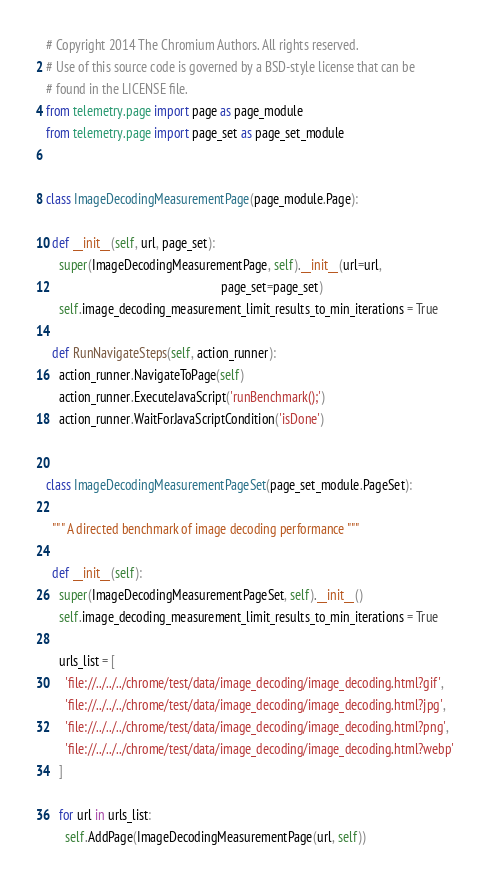<code> <loc_0><loc_0><loc_500><loc_500><_Python_># Copyright 2014 The Chromium Authors. All rights reserved.
# Use of this source code is governed by a BSD-style license that can be
# found in the LICENSE file.
from telemetry.page import page as page_module
from telemetry.page import page_set as page_set_module


class ImageDecodingMeasurementPage(page_module.Page):

  def __init__(self, url, page_set):
    super(ImageDecodingMeasurementPage, self).__init__(url=url,
                                                       page_set=page_set)
    self.image_decoding_measurement_limit_results_to_min_iterations = True

  def RunNavigateSteps(self, action_runner):
    action_runner.NavigateToPage(self)
    action_runner.ExecuteJavaScript('runBenchmark();')
    action_runner.WaitForJavaScriptCondition('isDone')


class ImageDecodingMeasurementPageSet(page_set_module.PageSet):

  """ A directed benchmark of image decoding performance """

  def __init__(self):
    super(ImageDecodingMeasurementPageSet, self).__init__()
    self.image_decoding_measurement_limit_results_to_min_iterations = True

    urls_list = [
      'file://../../../chrome/test/data/image_decoding/image_decoding.html?gif',
      'file://../../../chrome/test/data/image_decoding/image_decoding.html?jpg',
      'file://../../../chrome/test/data/image_decoding/image_decoding.html?png',
      'file://../../../chrome/test/data/image_decoding/image_decoding.html?webp'
    ]

    for url in urls_list:
      self.AddPage(ImageDecodingMeasurementPage(url, self))
</code> 